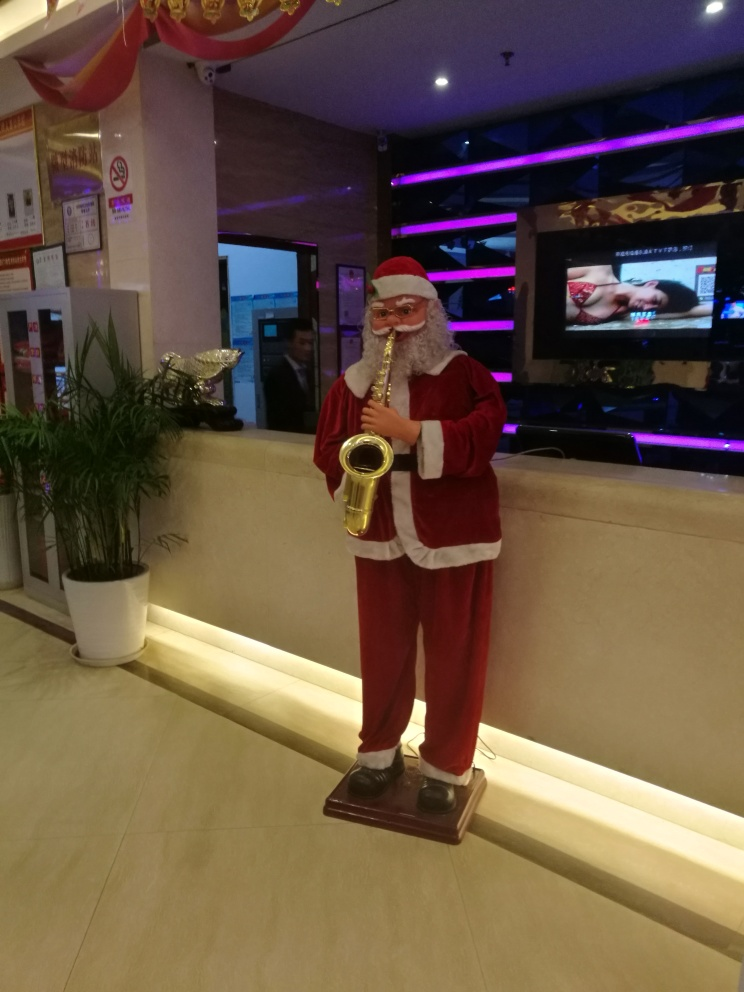What kind of mood or atmosphere does this image convey? The image conveys a festive and cheerful mood, commonly associated with holiday decorations like the santaclaustatue. However, the juxtaposition of the playful figure with the more formal and subdued environment of the background creates a somewhat contrasting atmosphere. 